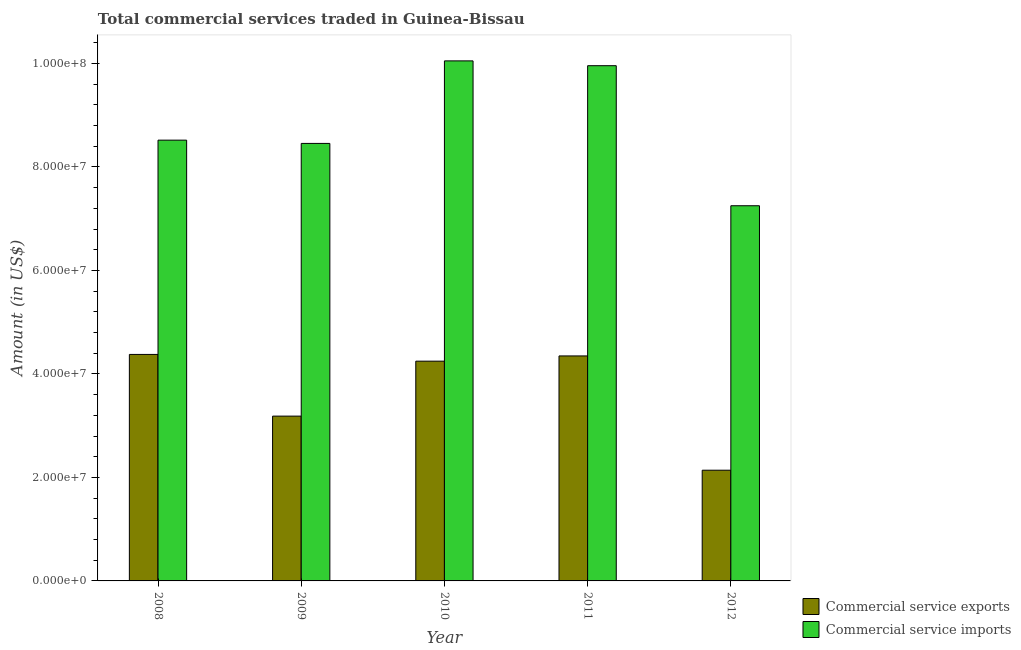Are the number of bars per tick equal to the number of legend labels?
Ensure brevity in your answer.  Yes. Are the number of bars on each tick of the X-axis equal?
Keep it short and to the point. Yes. How many bars are there on the 1st tick from the left?
Your answer should be compact. 2. How many bars are there on the 5th tick from the right?
Keep it short and to the point. 2. In how many cases, is the number of bars for a given year not equal to the number of legend labels?
Keep it short and to the point. 0. What is the amount of commercial service imports in 2010?
Your answer should be compact. 1.01e+08. Across all years, what is the maximum amount of commercial service imports?
Ensure brevity in your answer.  1.01e+08. Across all years, what is the minimum amount of commercial service imports?
Your answer should be compact. 7.25e+07. What is the total amount of commercial service imports in the graph?
Give a very brief answer. 4.42e+08. What is the difference between the amount of commercial service imports in 2009 and that in 2011?
Ensure brevity in your answer.  -1.50e+07. What is the difference between the amount of commercial service imports in 2011 and the amount of commercial service exports in 2008?
Offer a very short reply. 1.44e+07. What is the average amount of commercial service exports per year?
Provide a short and direct response. 3.66e+07. What is the ratio of the amount of commercial service imports in 2010 to that in 2011?
Give a very brief answer. 1.01. What is the difference between the highest and the second highest amount of commercial service imports?
Provide a short and direct response. 9.31e+05. What is the difference between the highest and the lowest amount of commercial service imports?
Ensure brevity in your answer.  2.80e+07. Is the sum of the amount of commercial service exports in 2008 and 2011 greater than the maximum amount of commercial service imports across all years?
Make the answer very short. Yes. What does the 1st bar from the left in 2009 represents?
Ensure brevity in your answer.  Commercial service exports. What does the 1st bar from the right in 2009 represents?
Your response must be concise. Commercial service imports. How many years are there in the graph?
Keep it short and to the point. 5. What is the difference between two consecutive major ticks on the Y-axis?
Your answer should be compact. 2.00e+07. Does the graph contain any zero values?
Offer a very short reply. No. Where does the legend appear in the graph?
Offer a terse response. Bottom right. How many legend labels are there?
Offer a very short reply. 2. What is the title of the graph?
Give a very brief answer. Total commercial services traded in Guinea-Bissau. What is the Amount (in US$) in Commercial service exports in 2008?
Offer a very short reply. 4.38e+07. What is the Amount (in US$) in Commercial service imports in 2008?
Your answer should be compact. 8.52e+07. What is the Amount (in US$) in Commercial service exports in 2009?
Give a very brief answer. 3.19e+07. What is the Amount (in US$) in Commercial service imports in 2009?
Your answer should be very brief. 8.46e+07. What is the Amount (in US$) of Commercial service exports in 2010?
Offer a very short reply. 4.25e+07. What is the Amount (in US$) of Commercial service imports in 2010?
Your answer should be compact. 1.01e+08. What is the Amount (in US$) in Commercial service exports in 2011?
Ensure brevity in your answer.  4.35e+07. What is the Amount (in US$) in Commercial service imports in 2011?
Provide a short and direct response. 9.96e+07. What is the Amount (in US$) of Commercial service exports in 2012?
Provide a succinct answer. 2.14e+07. What is the Amount (in US$) in Commercial service imports in 2012?
Offer a terse response. 7.25e+07. Across all years, what is the maximum Amount (in US$) of Commercial service exports?
Give a very brief answer. 4.38e+07. Across all years, what is the maximum Amount (in US$) in Commercial service imports?
Provide a succinct answer. 1.01e+08. Across all years, what is the minimum Amount (in US$) of Commercial service exports?
Your answer should be compact. 2.14e+07. Across all years, what is the minimum Amount (in US$) in Commercial service imports?
Ensure brevity in your answer.  7.25e+07. What is the total Amount (in US$) in Commercial service exports in the graph?
Give a very brief answer. 1.83e+08. What is the total Amount (in US$) in Commercial service imports in the graph?
Provide a short and direct response. 4.42e+08. What is the difference between the Amount (in US$) of Commercial service exports in 2008 and that in 2009?
Make the answer very short. 1.19e+07. What is the difference between the Amount (in US$) in Commercial service imports in 2008 and that in 2009?
Offer a very short reply. 6.30e+05. What is the difference between the Amount (in US$) in Commercial service exports in 2008 and that in 2010?
Provide a short and direct response. 1.30e+06. What is the difference between the Amount (in US$) of Commercial service imports in 2008 and that in 2010?
Keep it short and to the point. -1.53e+07. What is the difference between the Amount (in US$) in Commercial service exports in 2008 and that in 2011?
Offer a very short reply. 2.89e+05. What is the difference between the Amount (in US$) in Commercial service imports in 2008 and that in 2011?
Provide a short and direct response. -1.44e+07. What is the difference between the Amount (in US$) of Commercial service exports in 2008 and that in 2012?
Your answer should be compact. 2.24e+07. What is the difference between the Amount (in US$) in Commercial service imports in 2008 and that in 2012?
Ensure brevity in your answer.  1.27e+07. What is the difference between the Amount (in US$) of Commercial service exports in 2009 and that in 2010?
Keep it short and to the point. -1.06e+07. What is the difference between the Amount (in US$) in Commercial service imports in 2009 and that in 2010?
Give a very brief answer. -1.59e+07. What is the difference between the Amount (in US$) of Commercial service exports in 2009 and that in 2011?
Give a very brief answer. -1.16e+07. What is the difference between the Amount (in US$) of Commercial service imports in 2009 and that in 2011?
Give a very brief answer. -1.50e+07. What is the difference between the Amount (in US$) of Commercial service exports in 2009 and that in 2012?
Your answer should be very brief. 1.05e+07. What is the difference between the Amount (in US$) in Commercial service imports in 2009 and that in 2012?
Keep it short and to the point. 1.20e+07. What is the difference between the Amount (in US$) of Commercial service exports in 2010 and that in 2011?
Offer a very short reply. -1.01e+06. What is the difference between the Amount (in US$) of Commercial service imports in 2010 and that in 2011?
Keep it short and to the point. 9.31e+05. What is the difference between the Amount (in US$) in Commercial service exports in 2010 and that in 2012?
Keep it short and to the point. 2.11e+07. What is the difference between the Amount (in US$) of Commercial service imports in 2010 and that in 2012?
Ensure brevity in your answer.  2.80e+07. What is the difference between the Amount (in US$) in Commercial service exports in 2011 and that in 2012?
Give a very brief answer. 2.21e+07. What is the difference between the Amount (in US$) of Commercial service imports in 2011 and that in 2012?
Keep it short and to the point. 2.71e+07. What is the difference between the Amount (in US$) in Commercial service exports in 2008 and the Amount (in US$) in Commercial service imports in 2009?
Keep it short and to the point. -4.08e+07. What is the difference between the Amount (in US$) of Commercial service exports in 2008 and the Amount (in US$) of Commercial service imports in 2010?
Your response must be concise. -5.67e+07. What is the difference between the Amount (in US$) in Commercial service exports in 2008 and the Amount (in US$) in Commercial service imports in 2011?
Your answer should be compact. -5.58e+07. What is the difference between the Amount (in US$) in Commercial service exports in 2008 and the Amount (in US$) in Commercial service imports in 2012?
Ensure brevity in your answer.  -2.87e+07. What is the difference between the Amount (in US$) of Commercial service exports in 2009 and the Amount (in US$) of Commercial service imports in 2010?
Provide a succinct answer. -6.87e+07. What is the difference between the Amount (in US$) in Commercial service exports in 2009 and the Amount (in US$) in Commercial service imports in 2011?
Your answer should be very brief. -6.77e+07. What is the difference between the Amount (in US$) of Commercial service exports in 2009 and the Amount (in US$) of Commercial service imports in 2012?
Offer a terse response. -4.07e+07. What is the difference between the Amount (in US$) in Commercial service exports in 2010 and the Amount (in US$) in Commercial service imports in 2011?
Provide a short and direct response. -5.71e+07. What is the difference between the Amount (in US$) in Commercial service exports in 2010 and the Amount (in US$) in Commercial service imports in 2012?
Keep it short and to the point. -3.00e+07. What is the difference between the Amount (in US$) in Commercial service exports in 2011 and the Amount (in US$) in Commercial service imports in 2012?
Offer a terse response. -2.90e+07. What is the average Amount (in US$) in Commercial service exports per year?
Your response must be concise. 3.66e+07. What is the average Amount (in US$) in Commercial service imports per year?
Your answer should be very brief. 8.85e+07. In the year 2008, what is the difference between the Amount (in US$) in Commercial service exports and Amount (in US$) in Commercial service imports?
Keep it short and to the point. -4.14e+07. In the year 2009, what is the difference between the Amount (in US$) in Commercial service exports and Amount (in US$) in Commercial service imports?
Offer a terse response. -5.27e+07. In the year 2010, what is the difference between the Amount (in US$) of Commercial service exports and Amount (in US$) of Commercial service imports?
Your response must be concise. -5.80e+07. In the year 2011, what is the difference between the Amount (in US$) in Commercial service exports and Amount (in US$) in Commercial service imports?
Your answer should be very brief. -5.61e+07. In the year 2012, what is the difference between the Amount (in US$) in Commercial service exports and Amount (in US$) in Commercial service imports?
Offer a terse response. -5.11e+07. What is the ratio of the Amount (in US$) in Commercial service exports in 2008 to that in 2009?
Provide a short and direct response. 1.37. What is the ratio of the Amount (in US$) of Commercial service imports in 2008 to that in 2009?
Make the answer very short. 1.01. What is the ratio of the Amount (in US$) in Commercial service exports in 2008 to that in 2010?
Offer a very short reply. 1.03. What is the ratio of the Amount (in US$) of Commercial service imports in 2008 to that in 2010?
Your response must be concise. 0.85. What is the ratio of the Amount (in US$) of Commercial service exports in 2008 to that in 2011?
Offer a very short reply. 1.01. What is the ratio of the Amount (in US$) in Commercial service imports in 2008 to that in 2011?
Your response must be concise. 0.86. What is the ratio of the Amount (in US$) in Commercial service exports in 2008 to that in 2012?
Your answer should be very brief. 2.05. What is the ratio of the Amount (in US$) in Commercial service imports in 2008 to that in 2012?
Your answer should be very brief. 1.17. What is the ratio of the Amount (in US$) of Commercial service exports in 2009 to that in 2010?
Make the answer very short. 0.75. What is the ratio of the Amount (in US$) in Commercial service imports in 2009 to that in 2010?
Offer a very short reply. 0.84. What is the ratio of the Amount (in US$) in Commercial service exports in 2009 to that in 2011?
Make the answer very short. 0.73. What is the ratio of the Amount (in US$) in Commercial service imports in 2009 to that in 2011?
Your answer should be compact. 0.85. What is the ratio of the Amount (in US$) of Commercial service exports in 2009 to that in 2012?
Offer a terse response. 1.49. What is the ratio of the Amount (in US$) in Commercial service imports in 2009 to that in 2012?
Provide a short and direct response. 1.17. What is the ratio of the Amount (in US$) of Commercial service exports in 2010 to that in 2011?
Your response must be concise. 0.98. What is the ratio of the Amount (in US$) of Commercial service imports in 2010 to that in 2011?
Keep it short and to the point. 1.01. What is the ratio of the Amount (in US$) of Commercial service exports in 2010 to that in 2012?
Offer a terse response. 1.99. What is the ratio of the Amount (in US$) of Commercial service imports in 2010 to that in 2012?
Offer a very short reply. 1.39. What is the ratio of the Amount (in US$) of Commercial service exports in 2011 to that in 2012?
Provide a succinct answer. 2.03. What is the ratio of the Amount (in US$) of Commercial service imports in 2011 to that in 2012?
Ensure brevity in your answer.  1.37. What is the difference between the highest and the second highest Amount (in US$) in Commercial service exports?
Your response must be concise. 2.89e+05. What is the difference between the highest and the second highest Amount (in US$) of Commercial service imports?
Offer a very short reply. 9.31e+05. What is the difference between the highest and the lowest Amount (in US$) in Commercial service exports?
Provide a short and direct response. 2.24e+07. What is the difference between the highest and the lowest Amount (in US$) of Commercial service imports?
Provide a short and direct response. 2.80e+07. 